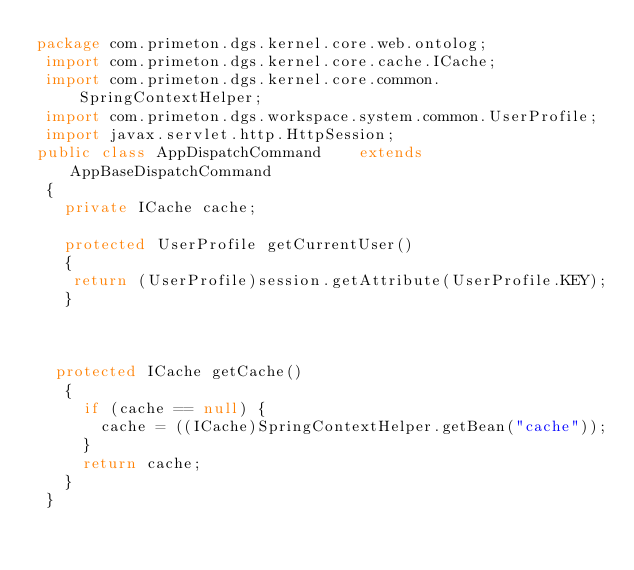<code> <loc_0><loc_0><loc_500><loc_500><_Java_>package com.primeton.dgs.kernel.core.web.ontolog;
 import com.primeton.dgs.kernel.core.cache.ICache;
 import com.primeton.dgs.kernel.core.common.SpringContextHelper;
 import com.primeton.dgs.workspace.system.common.UserProfile;
 import javax.servlet.http.HttpSession;
public class AppDispatchCommand    extends AppBaseDispatchCommand
 {
   private ICache cache;
  
   protected UserProfile getCurrentUser()
   {
    return (UserProfile)session.getAttribute(UserProfile.KEY);
   }
   

 
  protected ICache getCache()
   {
     if (cache == null) {
       cache = ((ICache)SpringContextHelper.getBean("cache"));
     }
     return cache;
   }
 }

</code> 